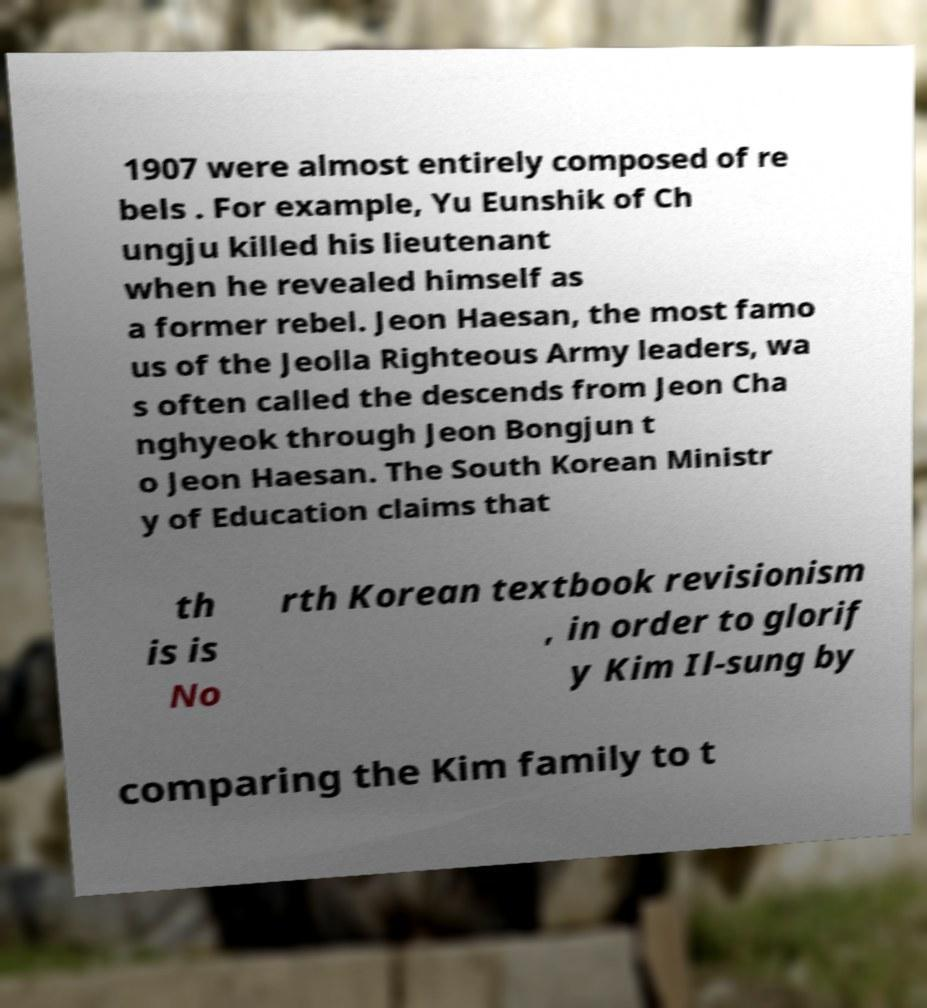What messages or text are displayed in this image? I need them in a readable, typed format. 1907 were almost entirely composed of re bels . For example, Yu Eunshik of Ch ungju killed his lieutenant when he revealed himself as a former rebel. Jeon Haesan, the most famo us of the Jeolla Righteous Army leaders, wa s often called the descends from Jeon Cha nghyeok through Jeon Bongjun t o Jeon Haesan. The South Korean Ministr y of Education claims that th is is No rth Korean textbook revisionism , in order to glorif y Kim Il-sung by comparing the Kim family to t 